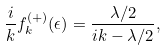Convert formula to latex. <formula><loc_0><loc_0><loc_500><loc_500>\frac { i } { k } f _ { k } ^ { ( + ) } ( \epsilon ) = \frac { \lambda / 2 } { i k - \lambda / 2 } ,</formula> 